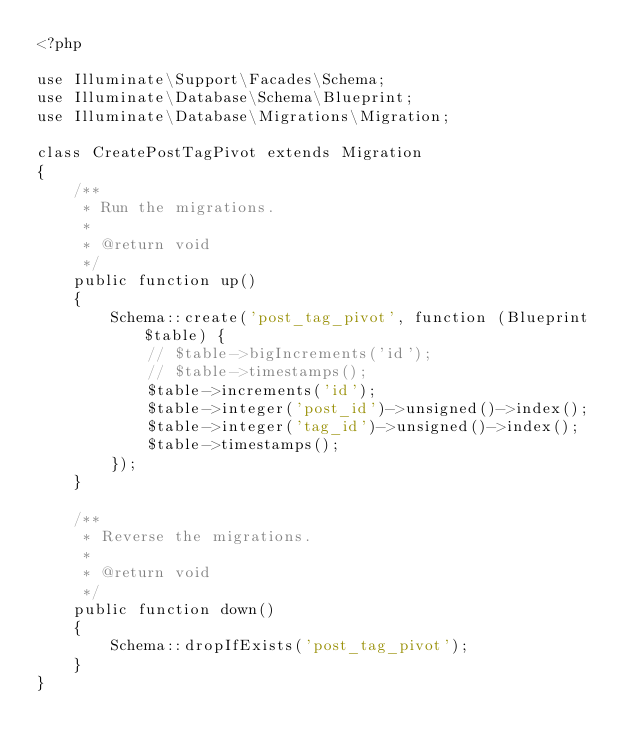<code> <loc_0><loc_0><loc_500><loc_500><_PHP_><?php

use Illuminate\Support\Facades\Schema;
use Illuminate\Database\Schema\Blueprint;
use Illuminate\Database\Migrations\Migration;

class CreatePostTagPivot extends Migration
{
    /**
     * Run the migrations.
     *
     * @return void
     */
    public function up()
    {
        Schema::create('post_tag_pivot', function (Blueprint $table) {
            // $table->bigIncrements('id');
            // $table->timestamps();
            $table->increments('id');
            $table->integer('post_id')->unsigned()->index();
            $table->integer('tag_id')->unsigned()->index();
            $table->timestamps();
        });
    }

    /**
     * Reverse the migrations.
     *
     * @return void
     */
    public function down()
    {
        Schema::dropIfExists('post_tag_pivot');
    }
}
</code> 